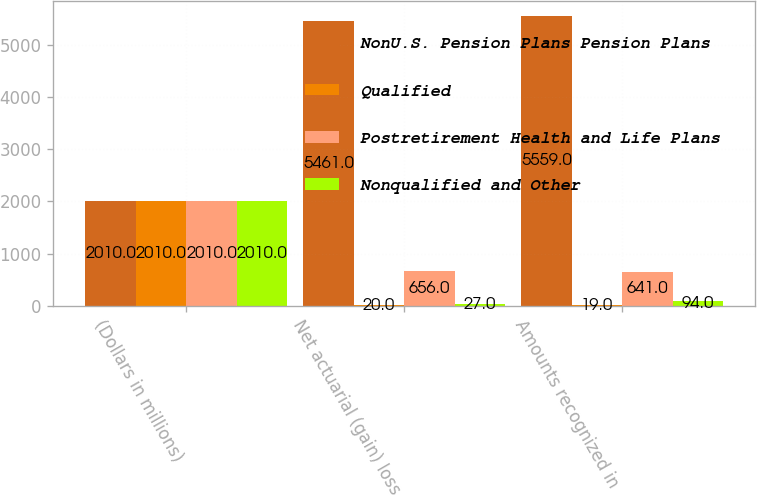<chart> <loc_0><loc_0><loc_500><loc_500><stacked_bar_chart><ecel><fcel>(Dollars in millions)<fcel>Net actuarial (gain) loss<fcel>Amounts recognized in<nl><fcel>NonU.S. Pension Plans Pension Plans<fcel>2010<fcel>5461<fcel>5559<nl><fcel>Qualified<fcel>2010<fcel>20<fcel>19<nl><fcel>Postretirement Health and Life Plans<fcel>2010<fcel>656<fcel>641<nl><fcel>Nonqualified and Other<fcel>2010<fcel>27<fcel>94<nl></chart> 